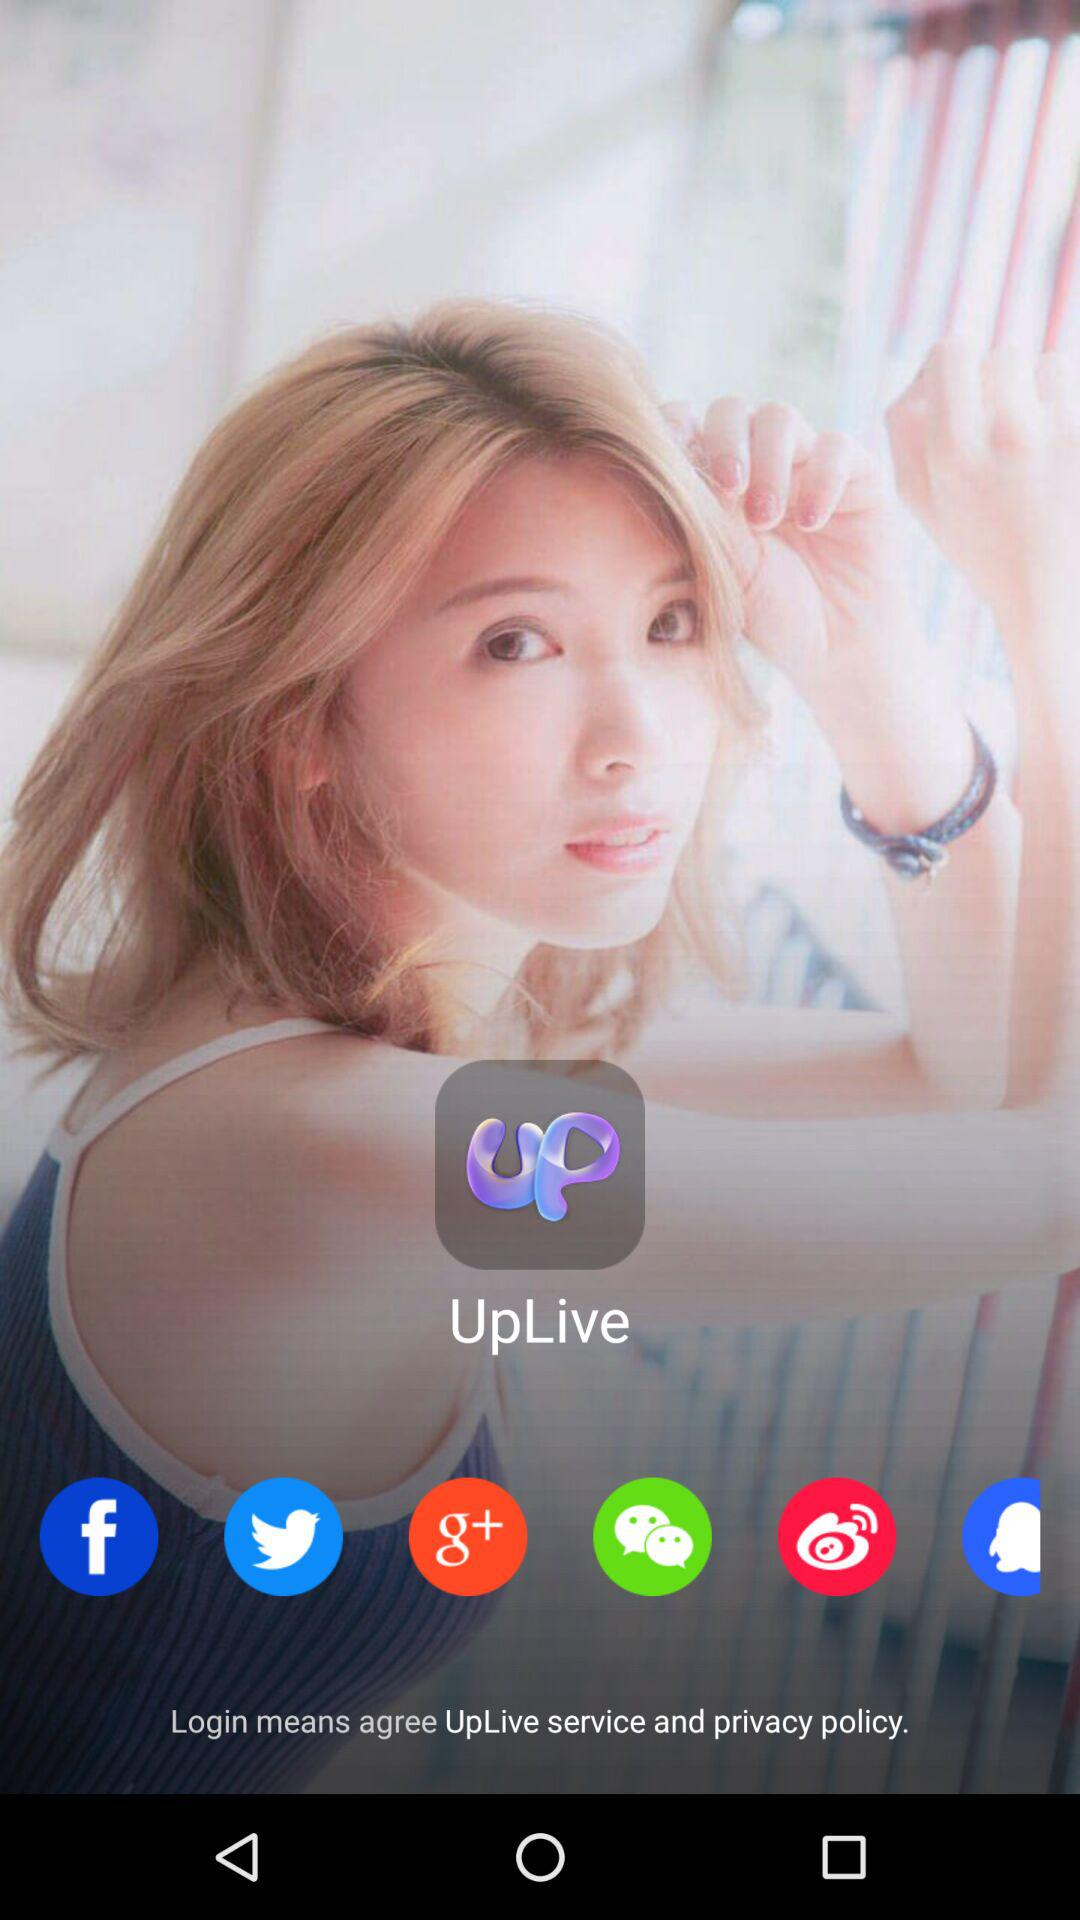What is the app name? The app name is "UpLive". 